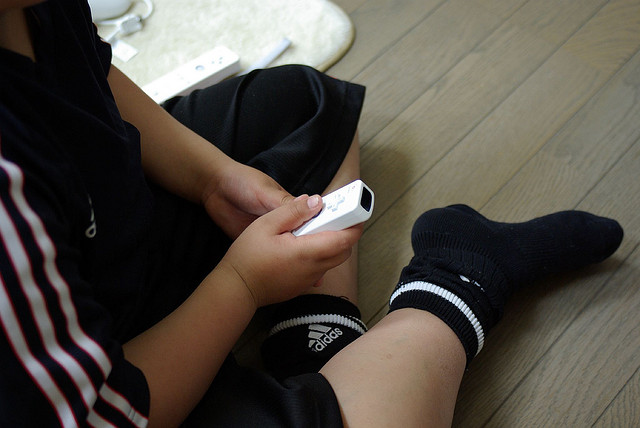<image>How artistic is this picture? It is ambiguous to determine how artistic this picture is. It can be subjective and depends on individual perspectives. How artistic is this picture? It is not very artistic. 